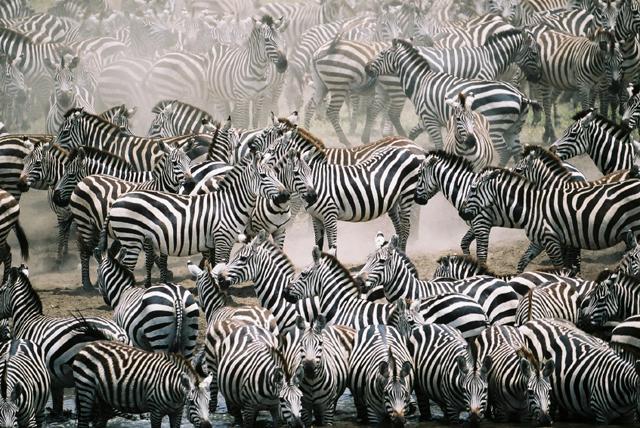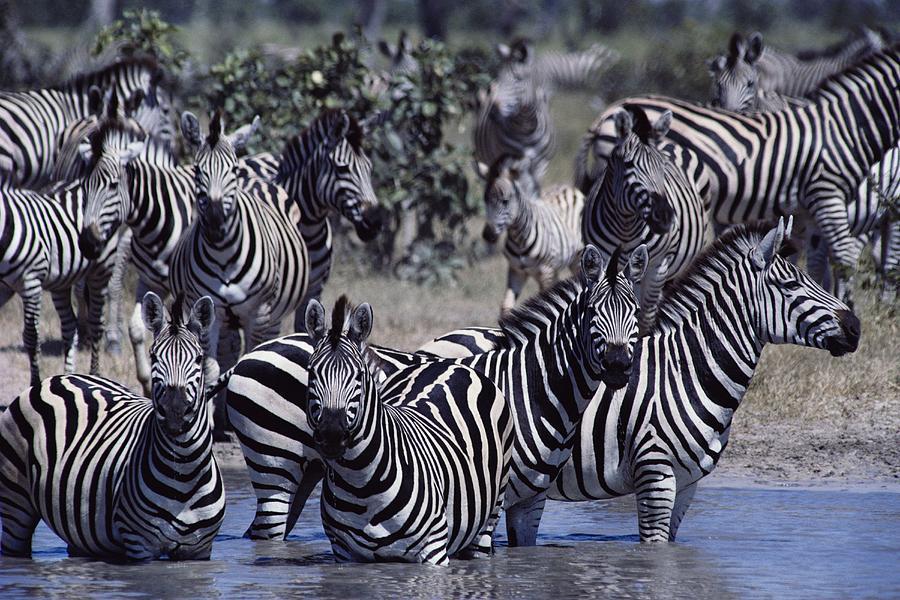The first image is the image on the left, the second image is the image on the right. Given the left and right images, does the statement "In the right image, there are zebras drinking from water." hold true? Answer yes or no. No. The first image is the image on the left, the second image is the image on the right. Considering the images on both sides, is "In one of the images, some of the zebras are in the water, and in the other image, none of the zebras are in the water." valid? Answer yes or no. No. 